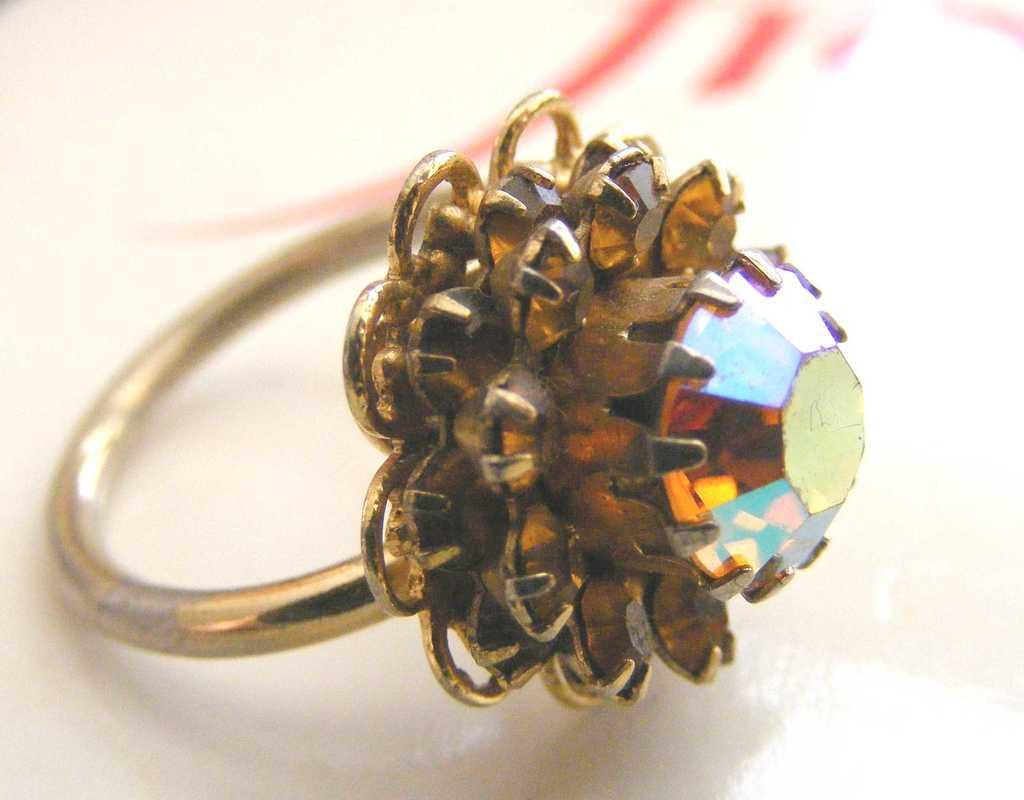Describe this image in one or two sentences. In this picture I can see there is a finger ring and it is in golden color with a gem, it is placed on a white surface. 